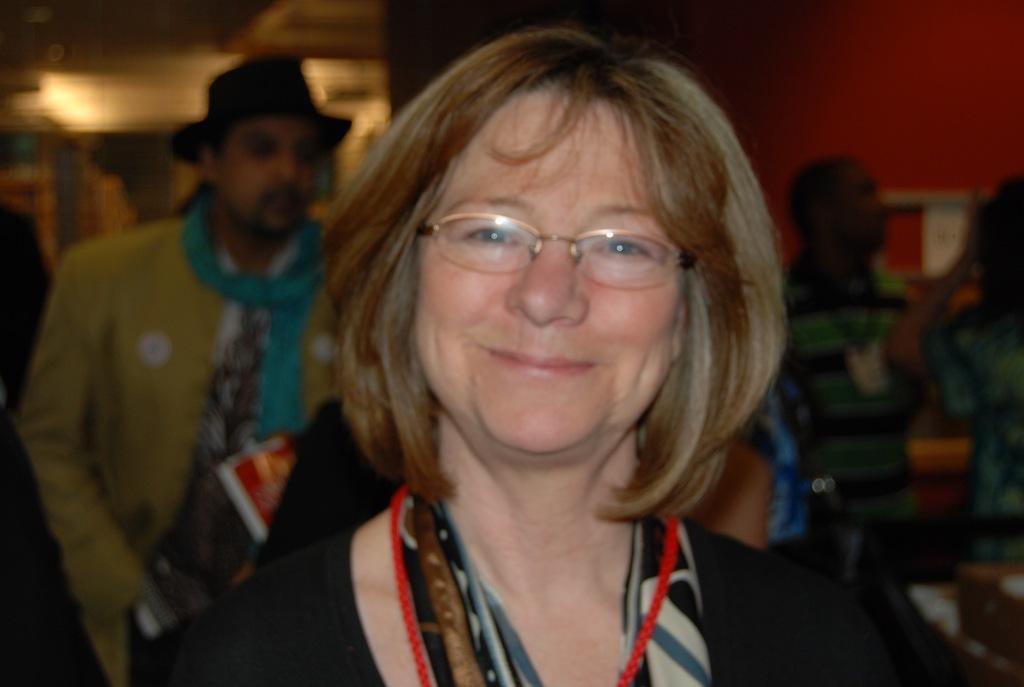How would you summarize this image in a sentence or two? In this picture I can see there is a woman standing here and smiling and there are some men standing in the backdrop and there is a red color wall in the backdrop. There are some lights attached on the ceiling. 